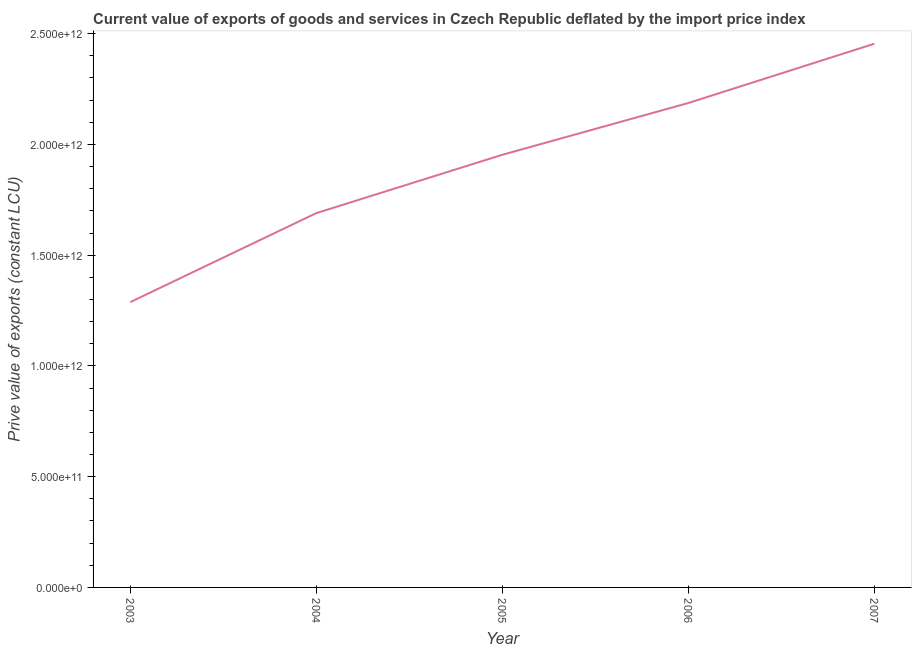What is the price value of exports in 2003?
Provide a short and direct response. 1.29e+12. Across all years, what is the maximum price value of exports?
Offer a very short reply. 2.45e+12. Across all years, what is the minimum price value of exports?
Your answer should be compact. 1.29e+12. What is the sum of the price value of exports?
Provide a short and direct response. 9.57e+12. What is the difference between the price value of exports in 2005 and 2007?
Give a very brief answer. -5.01e+11. What is the average price value of exports per year?
Offer a very short reply. 1.91e+12. What is the median price value of exports?
Provide a short and direct response. 1.95e+12. In how many years, is the price value of exports greater than 800000000000 LCU?
Offer a very short reply. 5. What is the ratio of the price value of exports in 2004 to that in 2006?
Your answer should be compact. 0.77. What is the difference between the highest and the second highest price value of exports?
Keep it short and to the point. 2.68e+11. Is the sum of the price value of exports in 2005 and 2006 greater than the maximum price value of exports across all years?
Give a very brief answer. Yes. What is the difference between the highest and the lowest price value of exports?
Provide a succinct answer. 1.17e+12. How many years are there in the graph?
Make the answer very short. 5. What is the difference between two consecutive major ticks on the Y-axis?
Offer a very short reply. 5.00e+11. Are the values on the major ticks of Y-axis written in scientific E-notation?
Ensure brevity in your answer.  Yes. What is the title of the graph?
Make the answer very short. Current value of exports of goods and services in Czech Republic deflated by the import price index. What is the label or title of the Y-axis?
Keep it short and to the point. Prive value of exports (constant LCU). What is the Prive value of exports (constant LCU) of 2003?
Make the answer very short. 1.29e+12. What is the Prive value of exports (constant LCU) of 2004?
Make the answer very short. 1.69e+12. What is the Prive value of exports (constant LCU) in 2005?
Your response must be concise. 1.95e+12. What is the Prive value of exports (constant LCU) in 2006?
Your answer should be compact. 2.19e+12. What is the Prive value of exports (constant LCU) of 2007?
Give a very brief answer. 2.45e+12. What is the difference between the Prive value of exports (constant LCU) in 2003 and 2004?
Provide a succinct answer. -4.02e+11. What is the difference between the Prive value of exports (constant LCU) in 2003 and 2005?
Make the answer very short. -6.65e+11. What is the difference between the Prive value of exports (constant LCU) in 2003 and 2006?
Offer a very short reply. -8.99e+11. What is the difference between the Prive value of exports (constant LCU) in 2003 and 2007?
Offer a terse response. -1.17e+12. What is the difference between the Prive value of exports (constant LCU) in 2004 and 2005?
Offer a terse response. -2.63e+11. What is the difference between the Prive value of exports (constant LCU) in 2004 and 2006?
Your answer should be very brief. -4.97e+11. What is the difference between the Prive value of exports (constant LCU) in 2004 and 2007?
Provide a succinct answer. -7.65e+11. What is the difference between the Prive value of exports (constant LCU) in 2005 and 2006?
Give a very brief answer. -2.34e+11. What is the difference between the Prive value of exports (constant LCU) in 2005 and 2007?
Keep it short and to the point. -5.01e+11. What is the difference between the Prive value of exports (constant LCU) in 2006 and 2007?
Ensure brevity in your answer.  -2.68e+11. What is the ratio of the Prive value of exports (constant LCU) in 2003 to that in 2004?
Keep it short and to the point. 0.76. What is the ratio of the Prive value of exports (constant LCU) in 2003 to that in 2005?
Offer a terse response. 0.66. What is the ratio of the Prive value of exports (constant LCU) in 2003 to that in 2006?
Give a very brief answer. 0.59. What is the ratio of the Prive value of exports (constant LCU) in 2003 to that in 2007?
Offer a very short reply. 0.53. What is the ratio of the Prive value of exports (constant LCU) in 2004 to that in 2005?
Ensure brevity in your answer.  0.86. What is the ratio of the Prive value of exports (constant LCU) in 2004 to that in 2006?
Make the answer very short. 0.77. What is the ratio of the Prive value of exports (constant LCU) in 2004 to that in 2007?
Your answer should be very brief. 0.69. What is the ratio of the Prive value of exports (constant LCU) in 2005 to that in 2006?
Offer a terse response. 0.89. What is the ratio of the Prive value of exports (constant LCU) in 2005 to that in 2007?
Offer a very short reply. 0.8. What is the ratio of the Prive value of exports (constant LCU) in 2006 to that in 2007?
Ensure brevity in your answer.  0.89. 